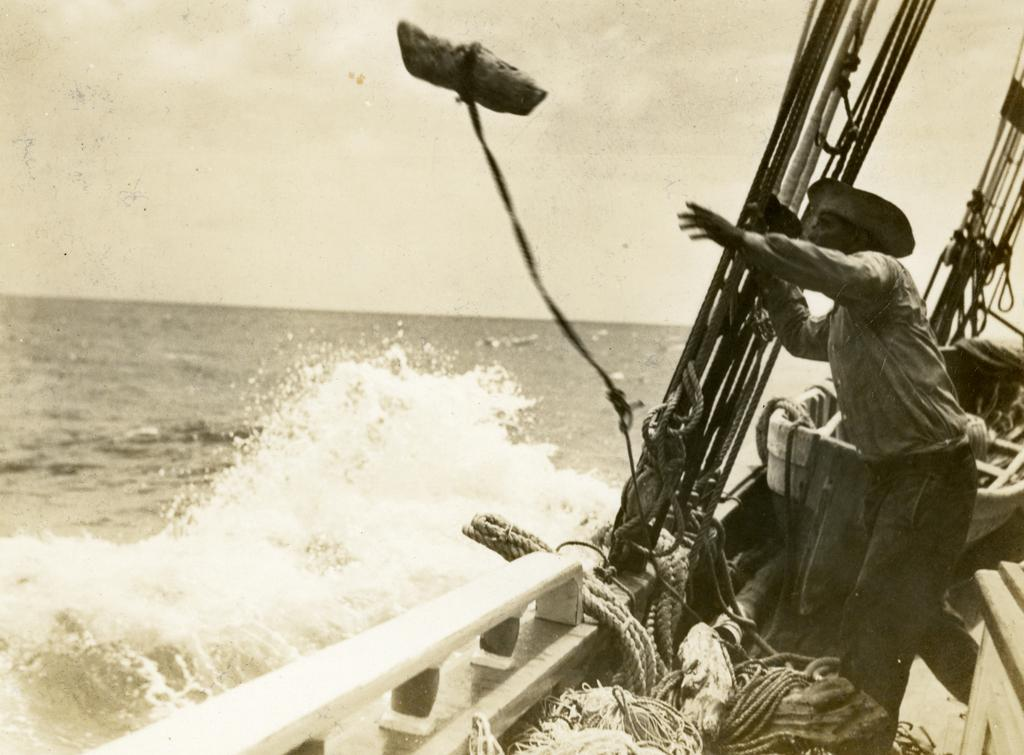What is the main subject of the image? There is a man standing in the image. What is the man wearing on his head? The man is wearing a hat. What objects can be seen in the image besides the man? There are ropes, water, and a boat visible in the image. What is the color scheme of the image? The image has a brown and white color scheme. What type of feather can be seen on the cake in the image? There is no cake or feather present in the image. What is the purpose of the boat in the image? The facts provided do not mention the purpose of the boat in the image. 